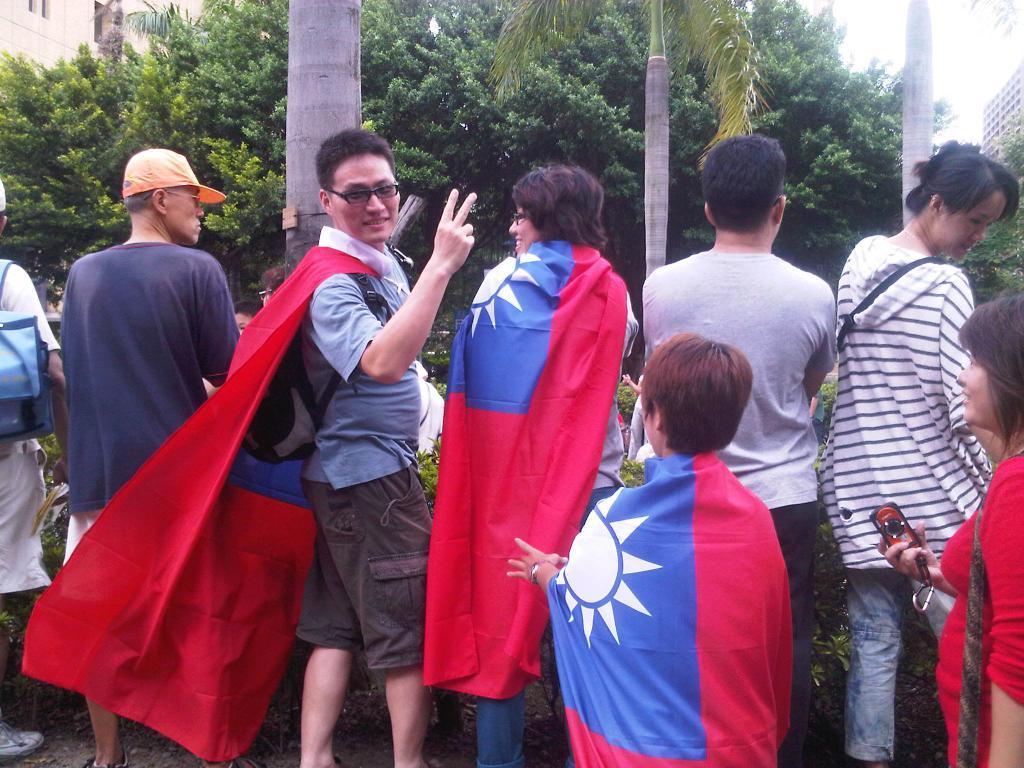Can you describe this image briefly? In this image there are a few people standing and few are holding their bags and objects in their hands, in front of them there are plants, trees and buildings. 